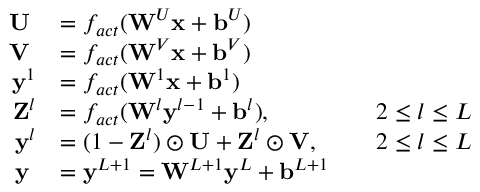<formula> <loc_0><loc_0><loc_500><loc_500>\begin{array} { r l r l } { U \, } & { = f _ { a c t } ( W ^ { U } x + b ^ { U } ) } & \\ { V \, } & { = f _ { a c t } ( W ^ { V } x + b ^ { V } ) } & \\ { y ^ { 1 } } & { = f _ { a c t } ( W ^ { 1 } x + b ^ { 1 } ) } & \\ { Z ^ { l } } & { = f _ { a c t } ( W ^ { l } y ^ { l - 1 } + b ^ { l } ) , } & & { 2 \leq l \leq L } \\ { y ^ { l } } & { = ( 1 - Z ^ { l } ) \odot U + Z ^ { l } \odot V , } & & { 2 \leq l \leq L } \\ { y \, } & { = y ^ { L + 1 } = W ^ { L + 1 } y ^ { L } + b ^ { L + 1 } } & \end{array}</formula> 